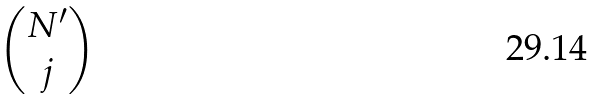Convert formula to latex. <formula><loc_0><loc_0><loc_500><loc_500>\begin{pmatrix} N ^ { \prime } \\ j \end{pmatrix}</formula> 